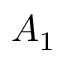Convert formula to latex. <formula><loc_0><loc_0><loc_500><loc_500>A _ { 1 }</formula> 